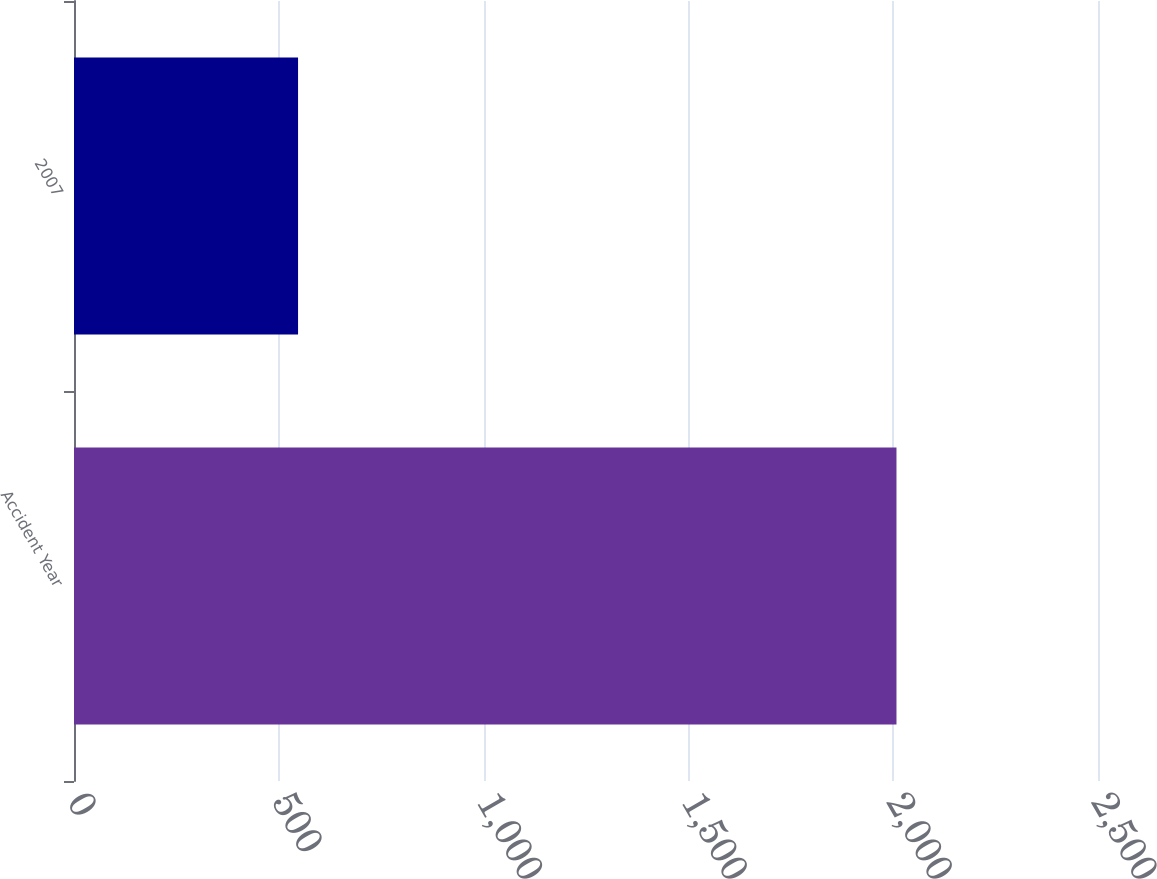Convert chart. <chart><loc_0><loc_0><loc_500><loc_500><bar_chart><fcel>Accident Year<fcel>2007<nl><fcel>2008<fcel>547<nl></chart> 